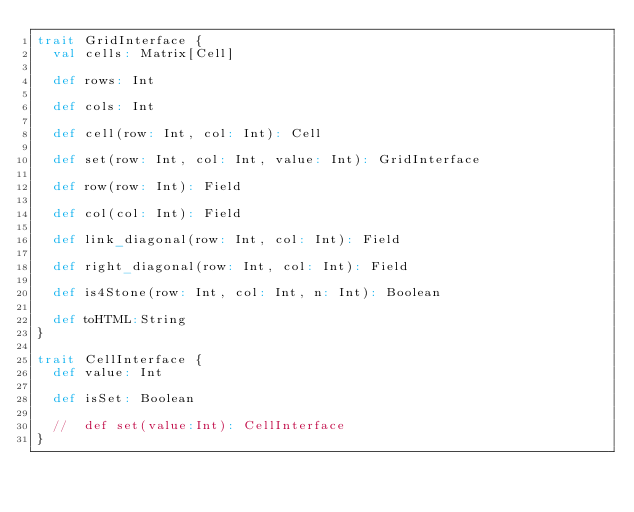<code> <loc_0><loc_0><loc_500><loc_500><_Scala_>trait GridInterface {
  val cells: Matrix[Cell]

  def rows: Int

  def cols: Int

  def cell(row: Int, col: Int): Cell

  def set(row: Int, col: Int, value: Int): GridInterface

  def row(row: Int): Field

  def col(col: Int): Field

  def link_diagonal(row: Int, col: Int): Field

  def right_diagonal(row: Int, col: Int): Field

  def is4Stone(row: Int, col: Int, n: Int): Boolean

  def toHTML:String
}

trait CellInterface {
  def value: Int

  def isSet: Boolean

  //  def set(value:Int): CellInterface
}</code> 